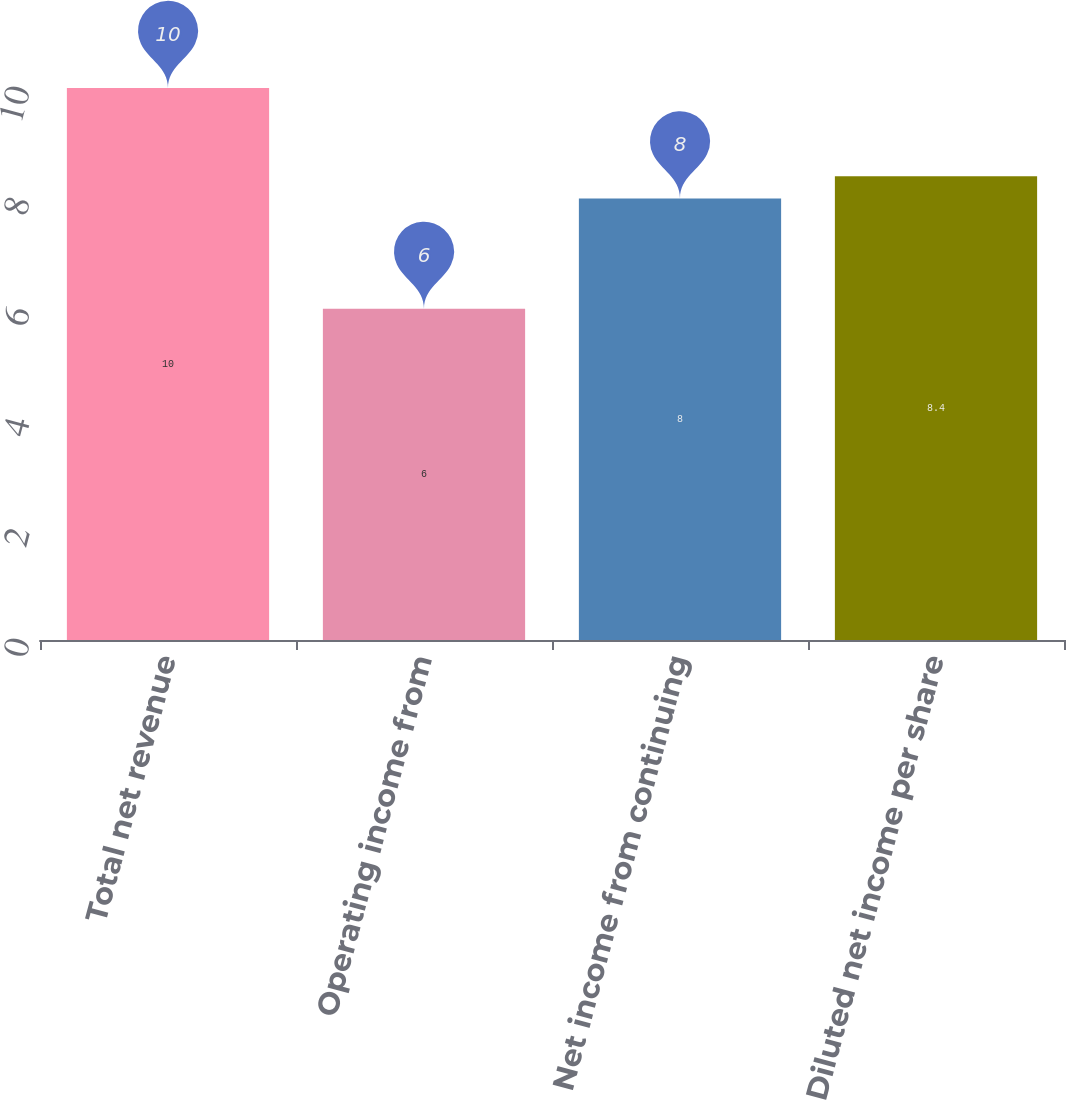Convert chart. <chart><loc_0><loc_0><loc_500><loc_500><bar_chart><fcel>Total net revenue<fcel>Operating income from<fcel>Net income from continuing<fcel>Diluted net income per share<nl><fcel>10<fcel>6<fcel>8<fcel>8.4<nl></chart> 